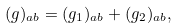Convert formula to latex. <formula><loc_0><loc_0><loc_500><loc_500>( g ) _ { a b } = ( g _ { 1 } ) _ { a b } + ( g _ { 2 } ) _ { a b } ,</formula> 